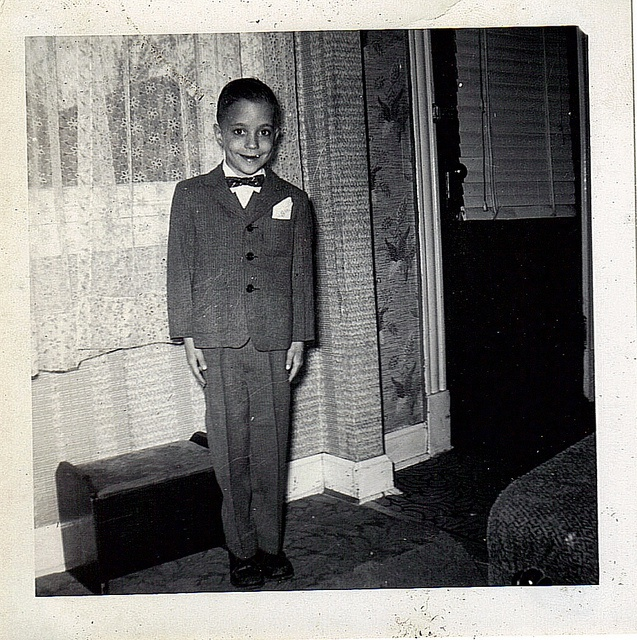Describe the objects in this image and their specific colors. I can see people in beige, gray, black, and darkgray tones, bed in beige, black, gray, and purple tones, and tie in beige, black, gray, and darkgray tones in this image. 